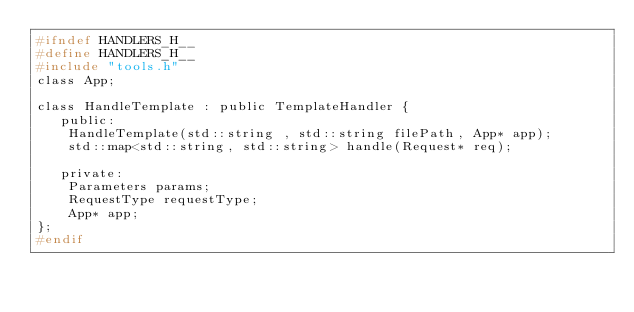Convert code to text. <code><loc_0><loc_0><loc_500><loc_500><_C_>#ifndef HANDLERS_H__
#define HANDLERS_H__
#include "tools.h"
class App;

class HandleTemplate : public TemplateHandler {
   public:
    HandleTemplate(std::string , std::string filePath, App* app);
    std::map<std::string, std::string> handle(Request* req);

   private:
    Parameters params;
    RequestType requestType;
    App* app;
};
#endif</code> 